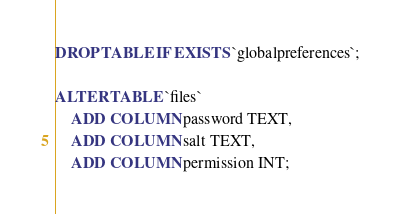<code> <loc_0><loc_0><loc_500><loc_500><_SQL_>DROP TABLE IF EXISTS `globalpreferences`;

ALTER TABLE `files`
	ADD COLUMN password TEXT,
	ADD COLUMN salt TEXT,
	ADD COLUMN permission INT;</code> 